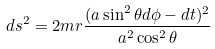Convert formula to latex. <formula><loc_0><loc_0><loc_500><loc_500>d s ^ { 2 } = 2 m r \frac { ( a \sin ^ { 2 } \theta d \phi - d t ) ^ { 2 } } { a ^ { 2 } \cos ^ { 2 } \theta }</formula> 